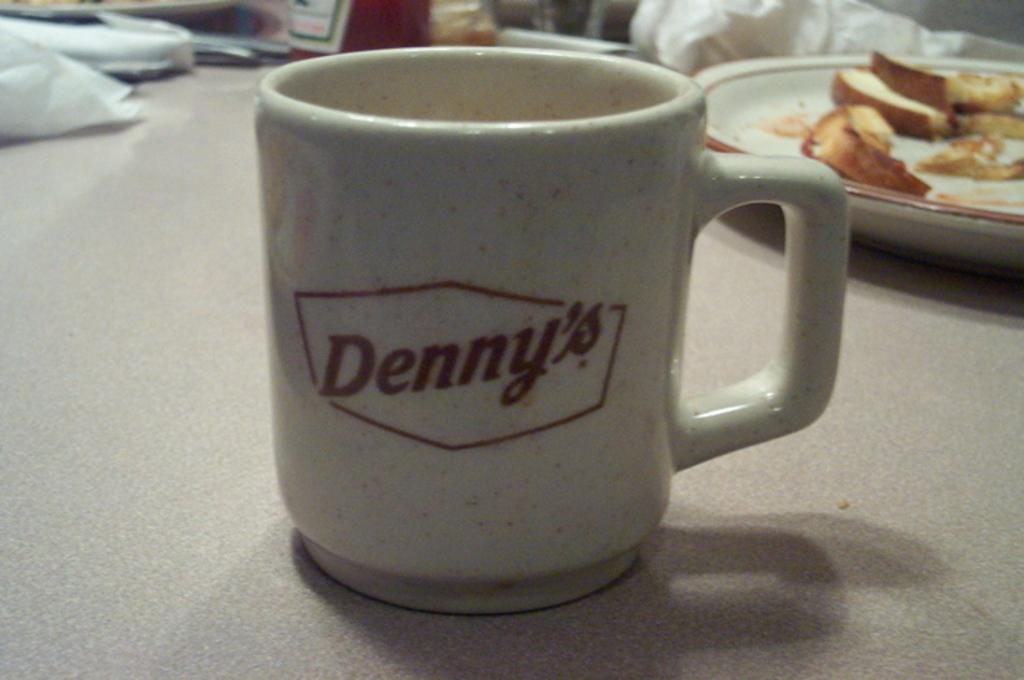Is denny's a restaurant in the us?
Your response must be concise. Answering does not require reading text in the image. 